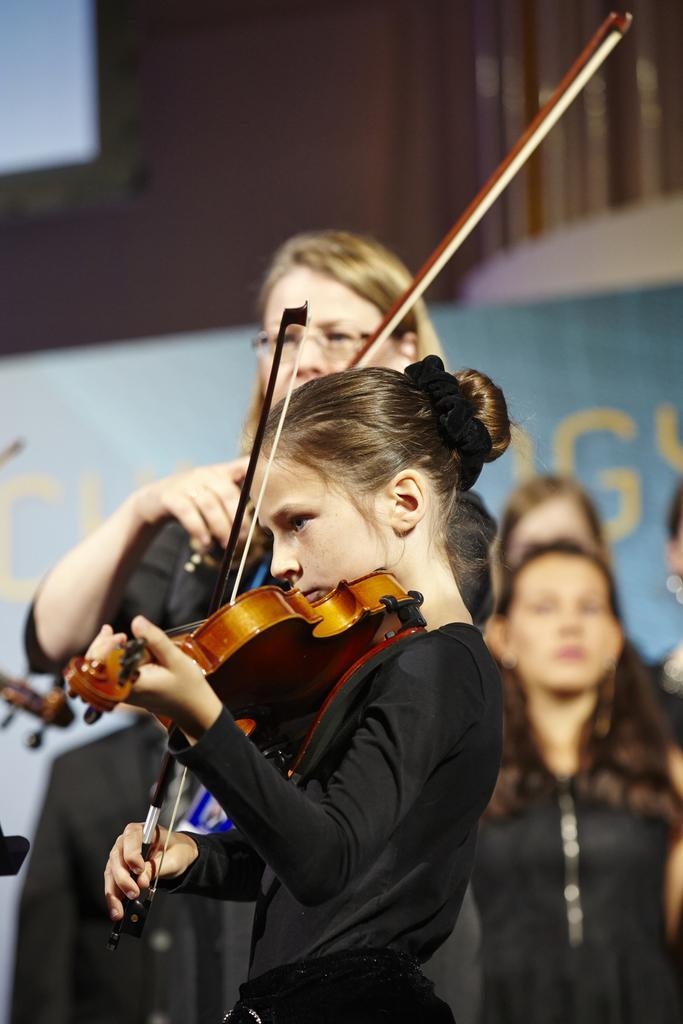Please provide a concise description of this image. In this image there is a small girl who is playing the piano and at the back side there are people who are watching the girl who is playing the piano. There is a woman who is beside the girl is also playing the piano. 